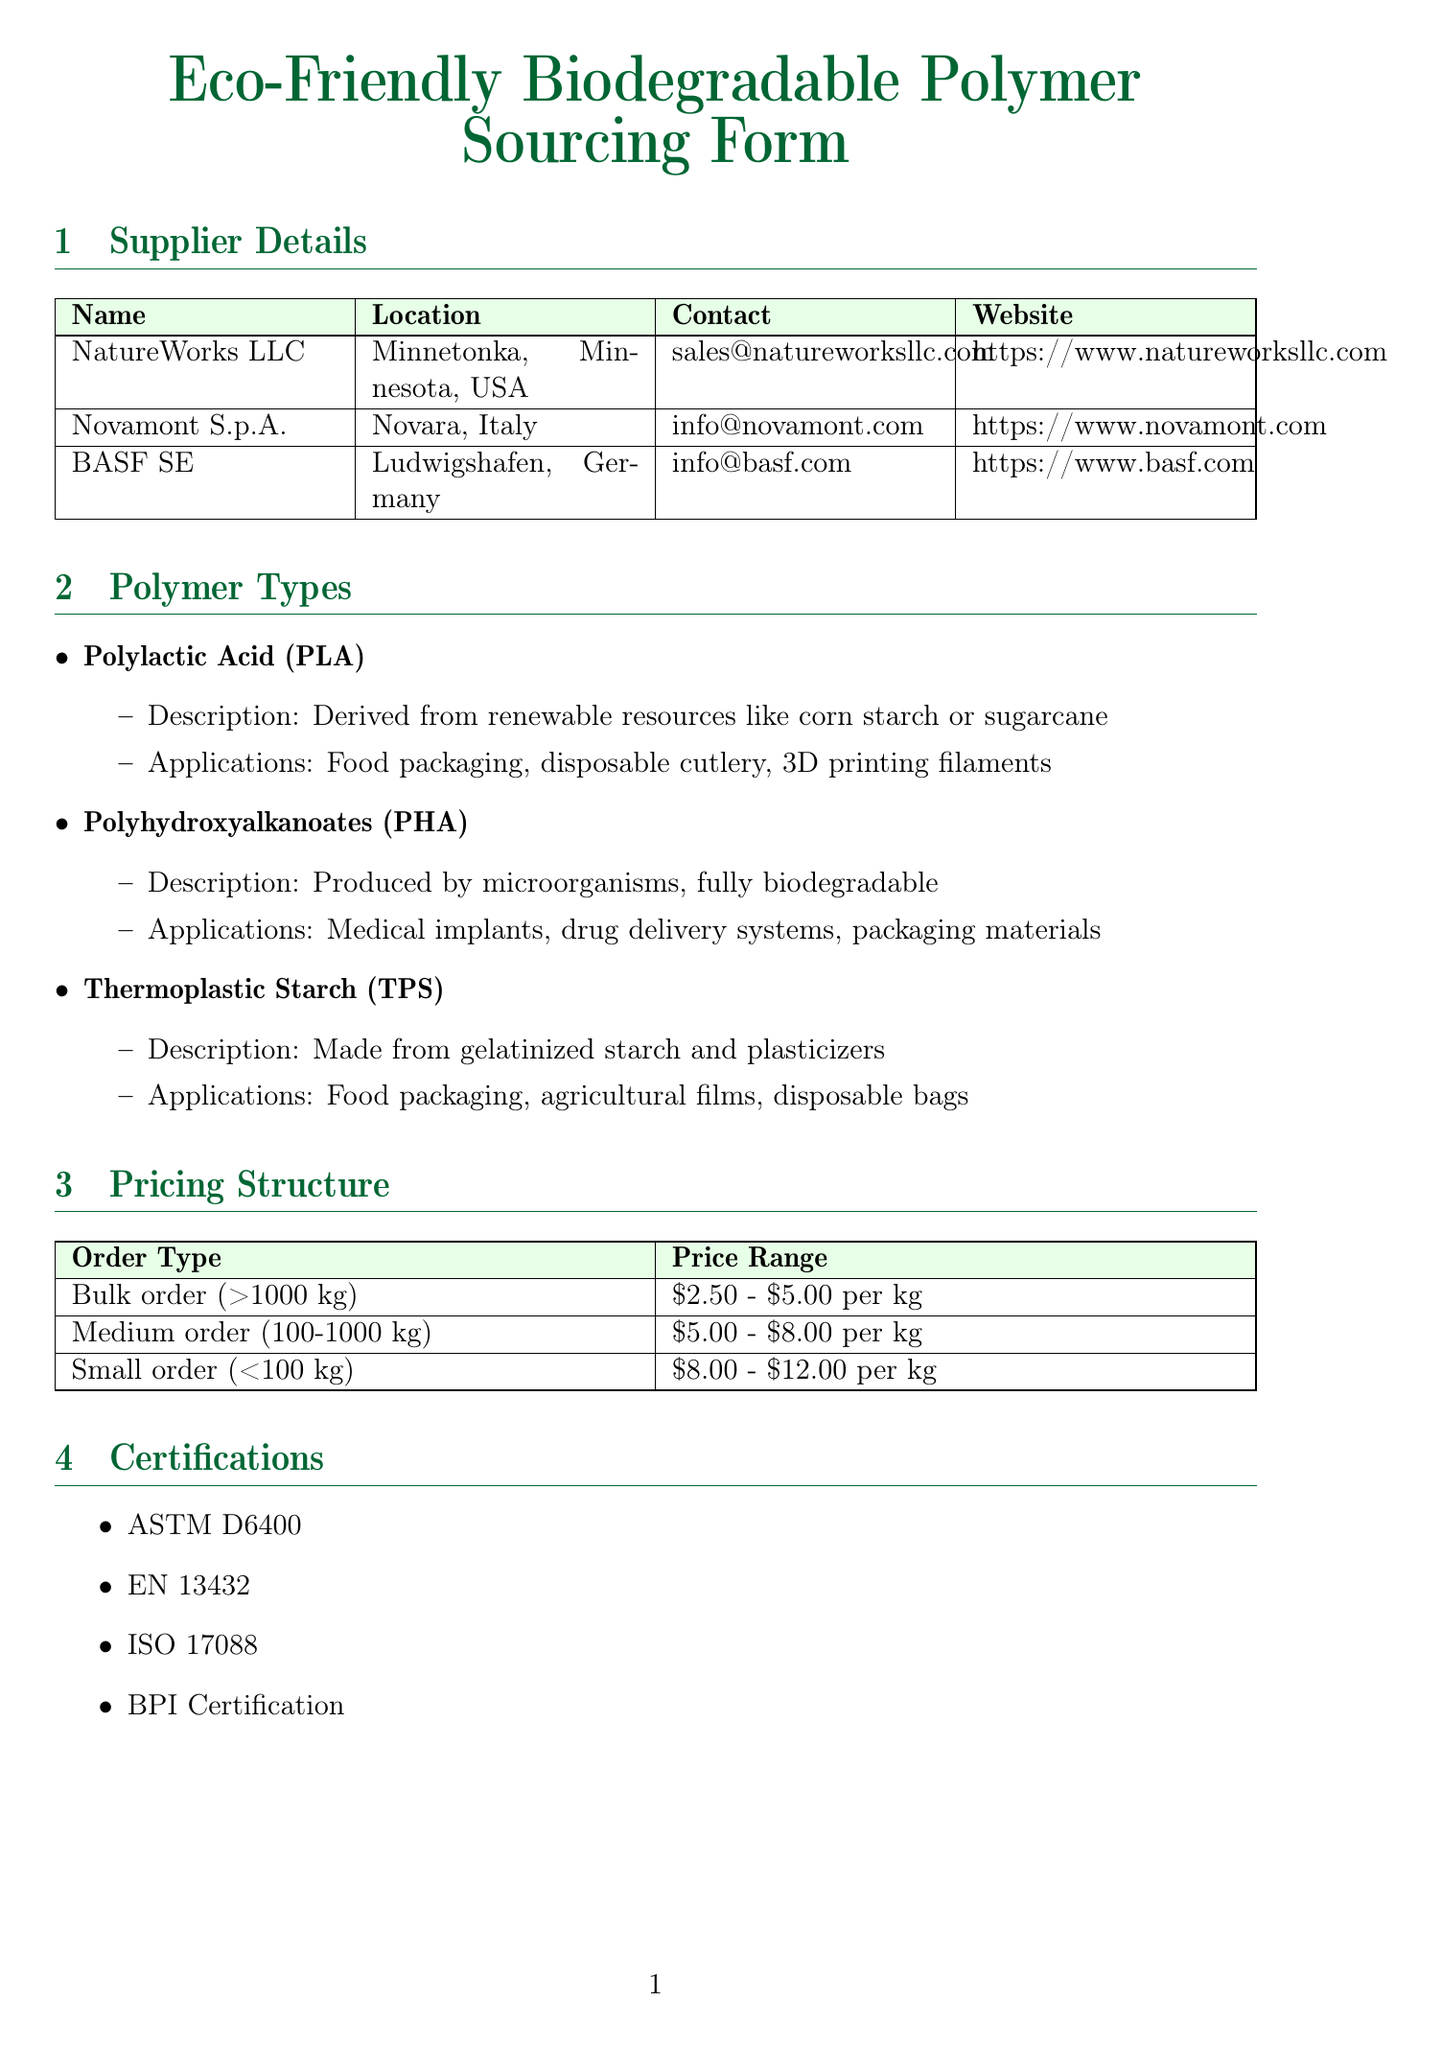what is the name of the first supplier? The name of the first supplier listed in the document is NatureWorks LLC.
Answer: NatureWorks LLC where is Novamont S.p.A. located? The document states that Novamont S.p.A. is located in Novara, Italy.
Answer: Novara, Italy what is the price range for a bulk order? The price range for a bulk order (>1000 kg) can be found under the pricing structure in the document.
Answer: $2.50 - $5.00 per kg which certification is not listed in the document? The question asks for a certification that is absent from the list provided, and all listed certifications must be considered.
Answer: None (all certifications are listed) what is one application of Polylactic Acid (PLA)? The document mentions several applications for PLA, and only one is required as an answer.
Answer: Food packaging how many types of sustainability metrics are listed? The count of sustainability metrics provided in the document must be tallied to answer this correctly.
Answer: Four what is the lead time associated with ordering materials? The document mentions additional considerations, but the lead time is not specifically quantified or detailed.
Answer: Not specified which polymer is produced by microorganisms? The document provides details on various polymers, and this question targets one specific aspect: the source of PHA.
Answer: Polyhydroxyalkanoates (PHA) 